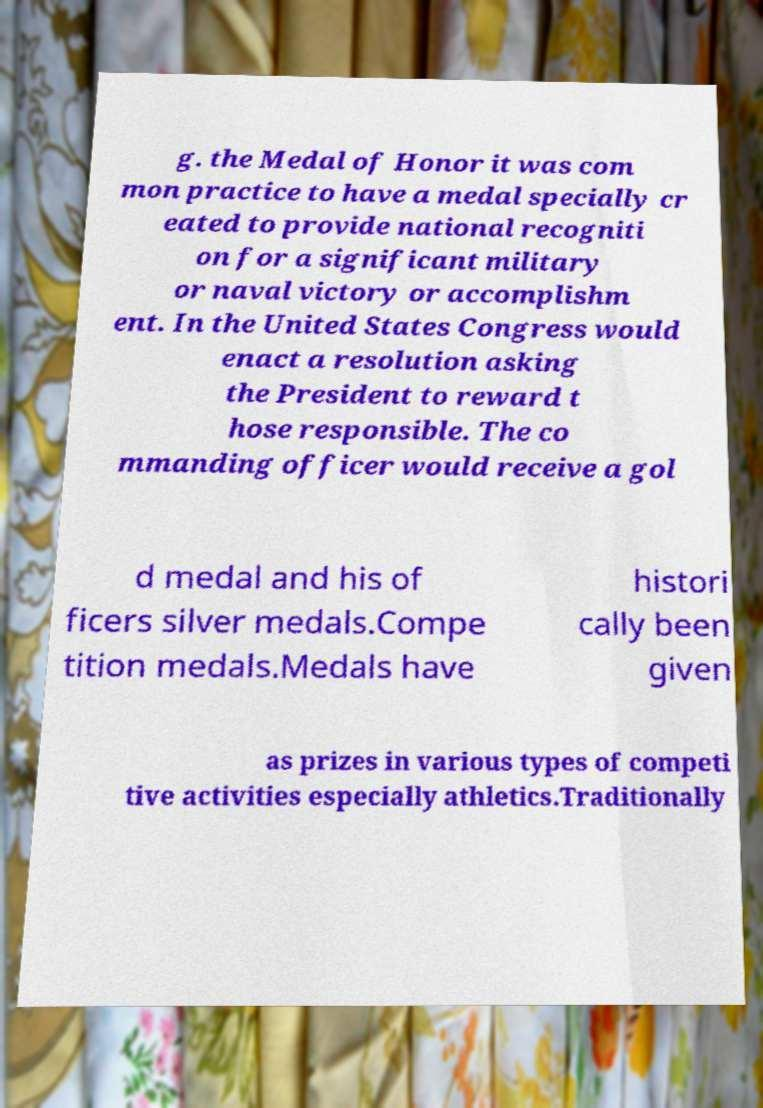There's text embedded in this image that I need extracted. Can you transcribe it verbatim? g. the Medal of Honor it was com mon practice to have a medal specially cr eated to provide national recogniti on for a significant military or naval victory or accomplishm ent. In the United States Congress would enact a resolution asking the President to reward t hose responsible. The co mmanding officer would receive a gol d medal and his of ficers silver medals.Compe tition medals.Medals have histori cally been given as prizes in various types of competi tive activities especially athletics.Traditionally 